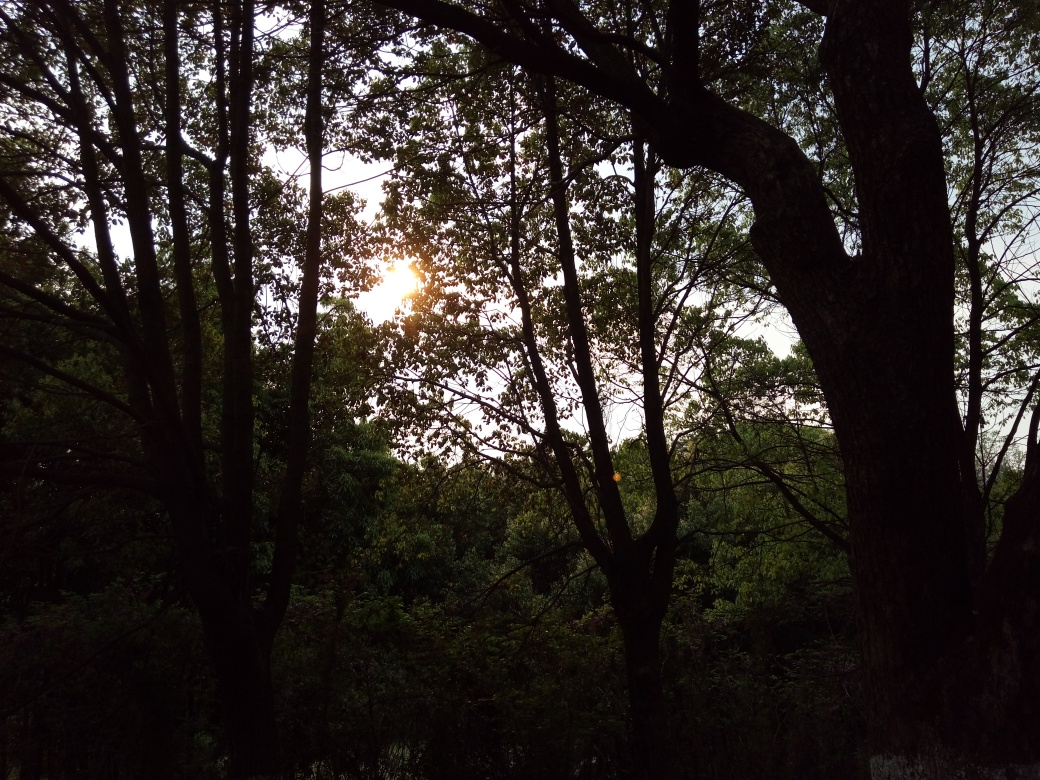Can you describe how the current time of day might be affecting the color palette of this image? The time of day, likely evening or early morning, contributes to a warmer color palette dominated by muted greens and earth tones, accentuated with golden hues from the sunlight. This lighting condition typically adds a serene, somewhat melancholic atmosphere to the scene. 